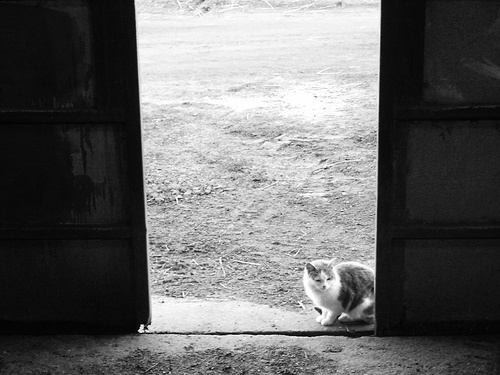Describe the objects in this image and their specific colors. I can see a cat in black, lightgray, gray, and darkgray tones in this image. 